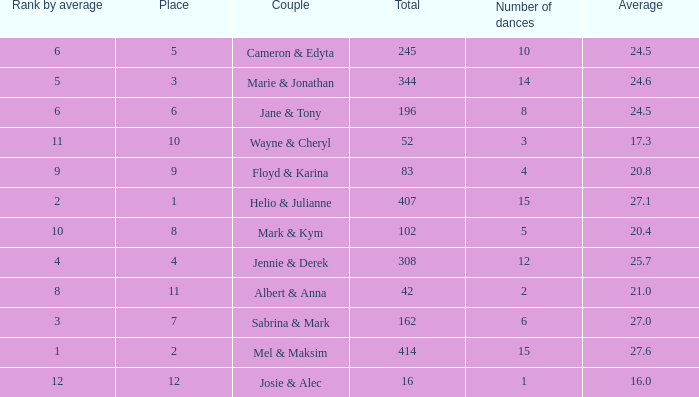What is the average place for a couple with the rank by average of 9 and total smaller than 83? None. 